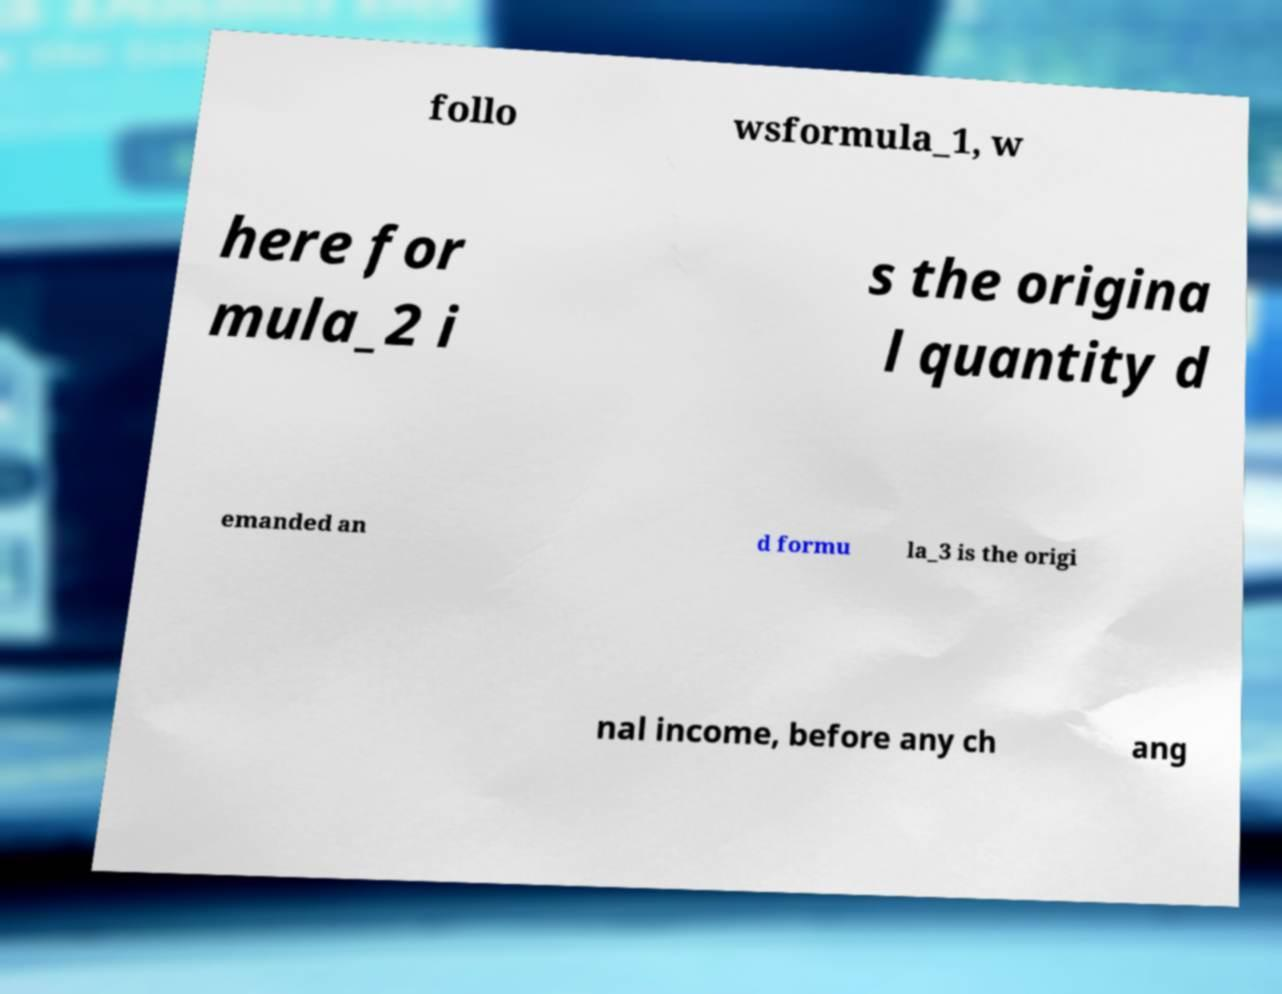Could you extract and type out the text from this image? follo wsformula_1, w here for mula_2 i s the origina l quantity d emanded an d formu la_3 is the origi nal income, before any ch ang 